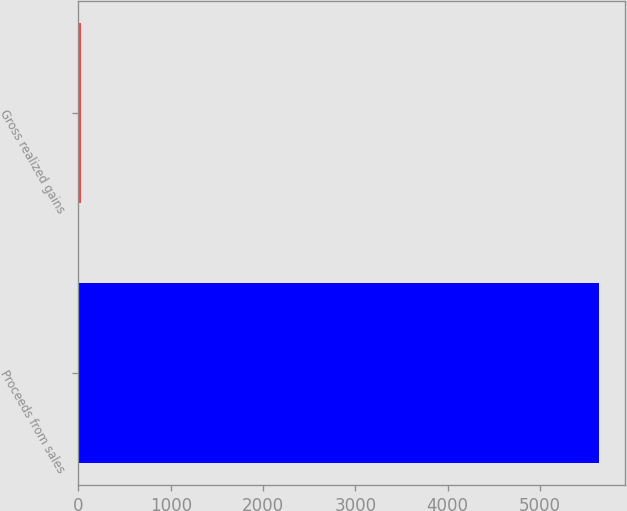Convert chart. <chart><loc_0><loc_0><loc_500><loc_500><bar_chart><fcel>Proceeds from sales<fcel>Gross realized gains<nl><fcel>5640<fcel>33<nl></chart> 